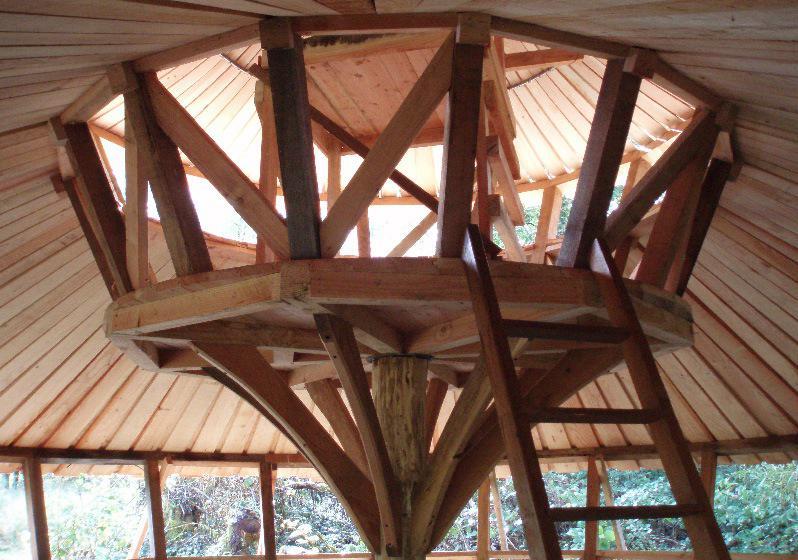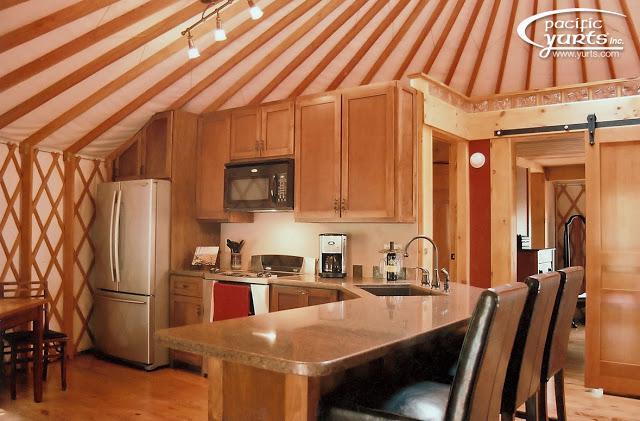The first image is the image on the left, the second image is the image on the right. Considering the images on both sides, is "All images show the outside of a yurt." valid? Answer yes or no. No. 